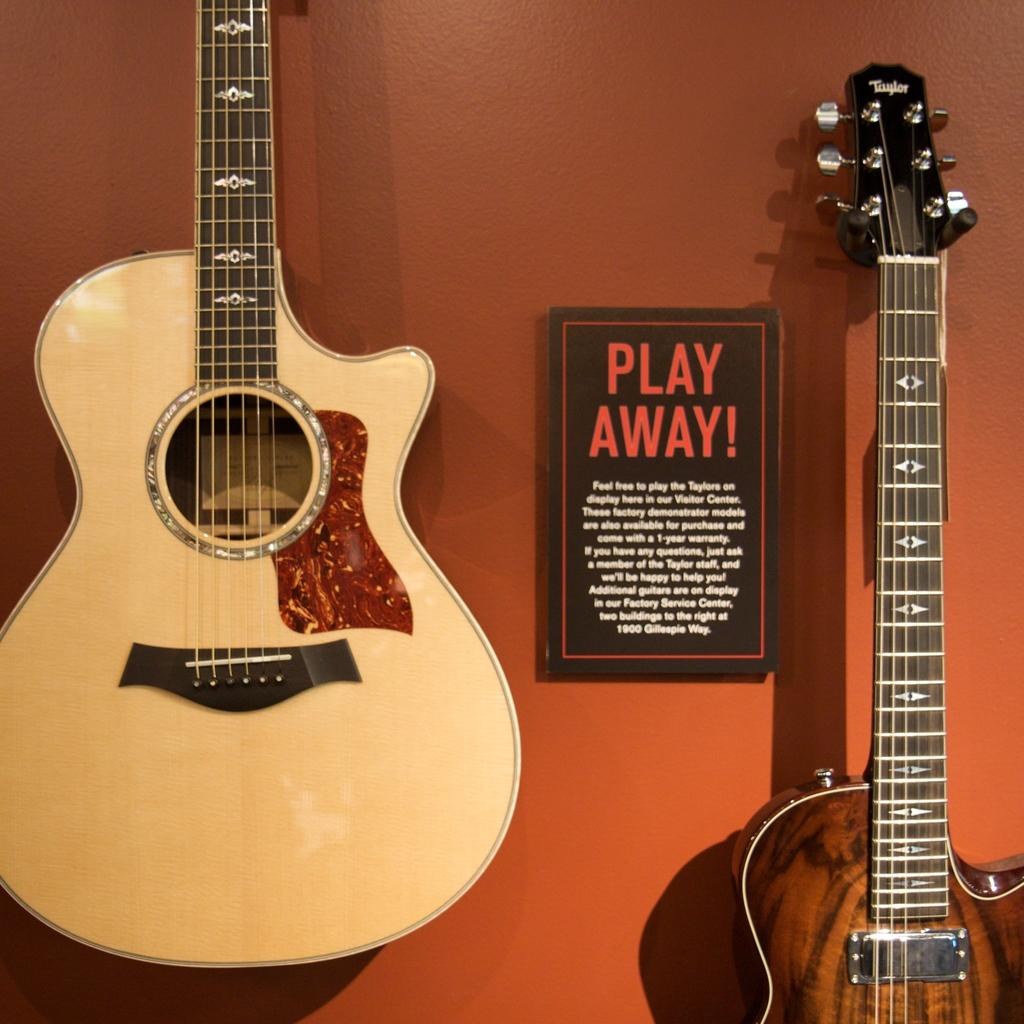What musical instruments are present in the image? There are two guitars in the image. What can be seen on the wall in the image? There is a board on the wall in the image. What color is the wall in the background of the image? The background of the image features an orange color wall. Can you tell me how much wealth the ghost in the image possesses? There is no ghost present in the image, so it is not possible to determine the wealth of a ghost. 